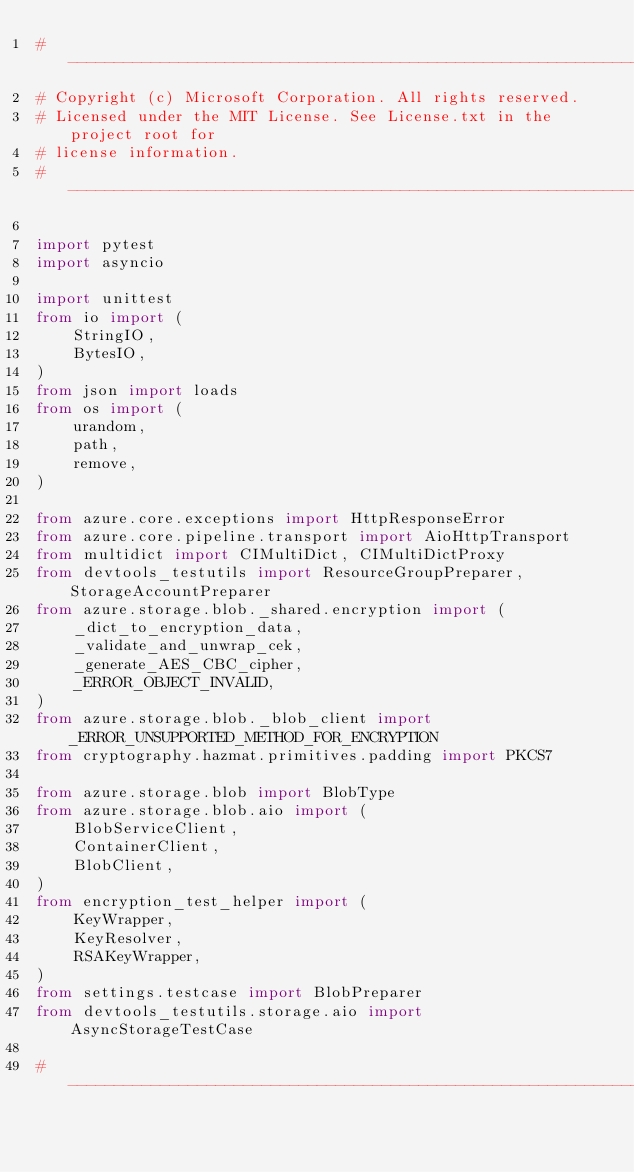<code> <loc_0><loc_0><loc_500><loc_500><_Python_># -------------------------------------------------------------------------
# Copyright (c) Microsoft Corporation. All rights reserved.
# Licensed under the MIT License. See License.txt in the project root for
# license information.
# --------------------------------------------------------------------------

import pytest
import asyncio

import unittest
from io import (
    StringIO,
    BytesIO,
)
from json import loads
from os import (
    urandom,
    path,
    remove,
)

from azure.core.exceptions import HttpResponseError
from azure.core.pipeline.transport import AioHttpTransport
from multidict import CIMultiDict, CIMultiDictProxy
from devtools_testutils import ResourceGroupPreparer, StorageAccountPreparer
from azure.storage.blob._shared.encryption import (
    _dict_to_encryption_data,
    _validate_and_unwrap_cek,
    _generate_AES_CBC_cipher,
    _ERROR_OBJECT_INVALID,
)
from azure.storage.blob._blob_client import _ERROR_UNSUPPORTED_METHOD_FOR_ENCRYPTION
from cryptography.hazmat.primitives.padding import PKCS7

from azure.storage.blob import BlobType
from azure.storage.blob.aio import (
    BlobServiceClient,
    ContainerClient,
    BlobClient,
)
from encryption_test_helper import (
    KeyWrapper,
    KeyResolver,
    RSAKeyWrapper,
)
from settings.testcase import BlobPreparer
from devtools_testutils.storage.aio import AsyncStorageTestCase

# ------------------------------------------------------------------------------</code> 